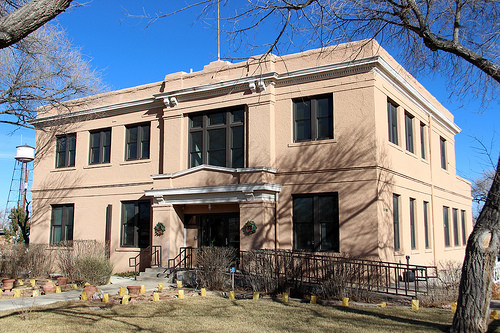<image>
Can you confirm if the tree is on the building? No. The tree is not positioned on the building. They may be near each other, but the tree is not supported by or resting on top of the building. 